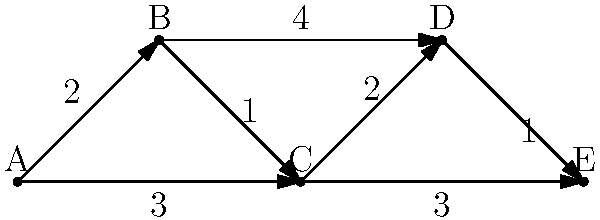In the network of government agencies shown above, where each node represents an agency and each edge represents a communication channel with its associated time cost (in hours), what is the shortest path from agency A to agency E, and what is the total time required for this path? To find the shortest path from agency A to agency E, we need to consider all possible paths and their total times. Let's examine each path step-by-step:

1. Path A → B → C → E:
   Time = 2 + 1 + 3 = 6 hours

2. Path A → B → D → E:
   Time = 2 + 4 + 1 = 7 hours

3. Path A → B → C → D → E:
   Time = 2 + 1 + 2 + 1 = 6 hours

4. Path A → C → E:
   Time = 3 + 3 = 6 hours

5. Path A → C → D → E:
   Time = 3 + 2 + 1 = 6 hours

We can see that there are three paths with the shortest total time of 6 hours:
- A → B → C → E
- A → B → C → D → E
- A → C → E

Among these, the path with the fewest agencies (nodes) is A → C → E.

Therefore, the shortest path from agency A to agency E is A → C → E, with a total time of 6 hours.
Answer: A → C → E, 6 hours 